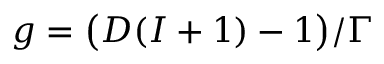Convert formula to latex. <formula><loc_0><loc_0><loc_500><loc_500>g = \left ( D ( I + 1 ) - 1 \right ) / \Gamma</formula> 